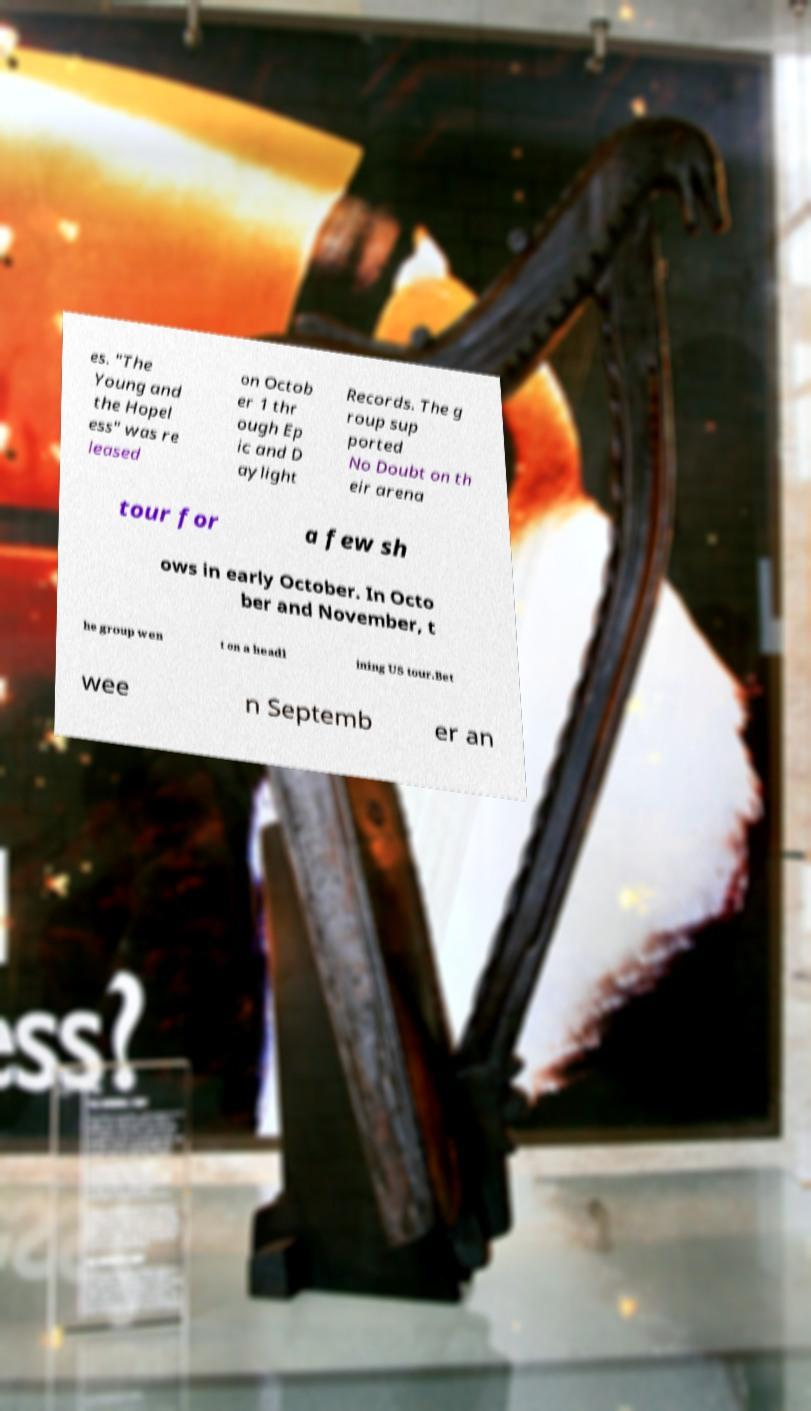Please read and relay the text visible in this image. What does it say? es. "The Young and the Hopel ess" was re leased on Octob er 1 thr ough Ep ic and D aylight Records. The g roup sup ported No Doubt on th eir arena tour for a few sh ows in early October. In Octo ber and November, t he group wen t on a headl ining US tour.Bet wee n Septemb er an 